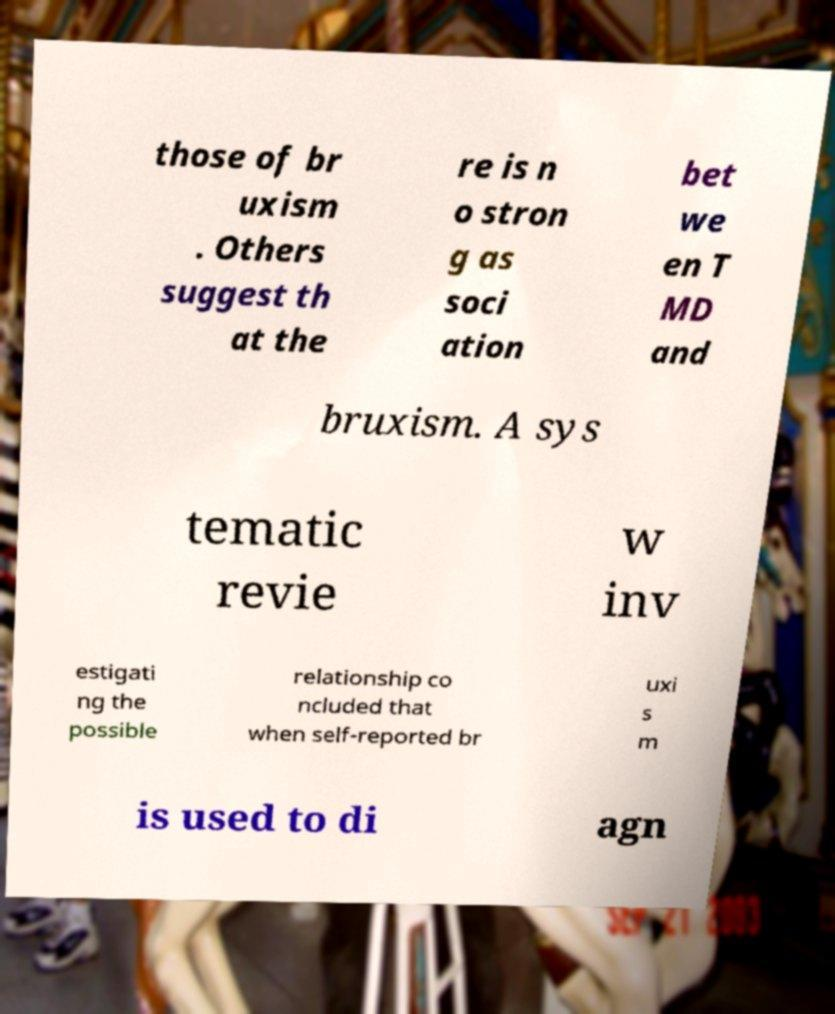Can you read and provide the text displayed in the image?This photo seems to have some interesting text. Can you extract and type it out for me? those of br uxism . Others suggest th at the re is n o stron g as soci ation bet we en T MD and bruxism. A sys tematic revie w inv estigati ng the possible relationship co ncluded that when self-reported br uxi s m is used to di agn 